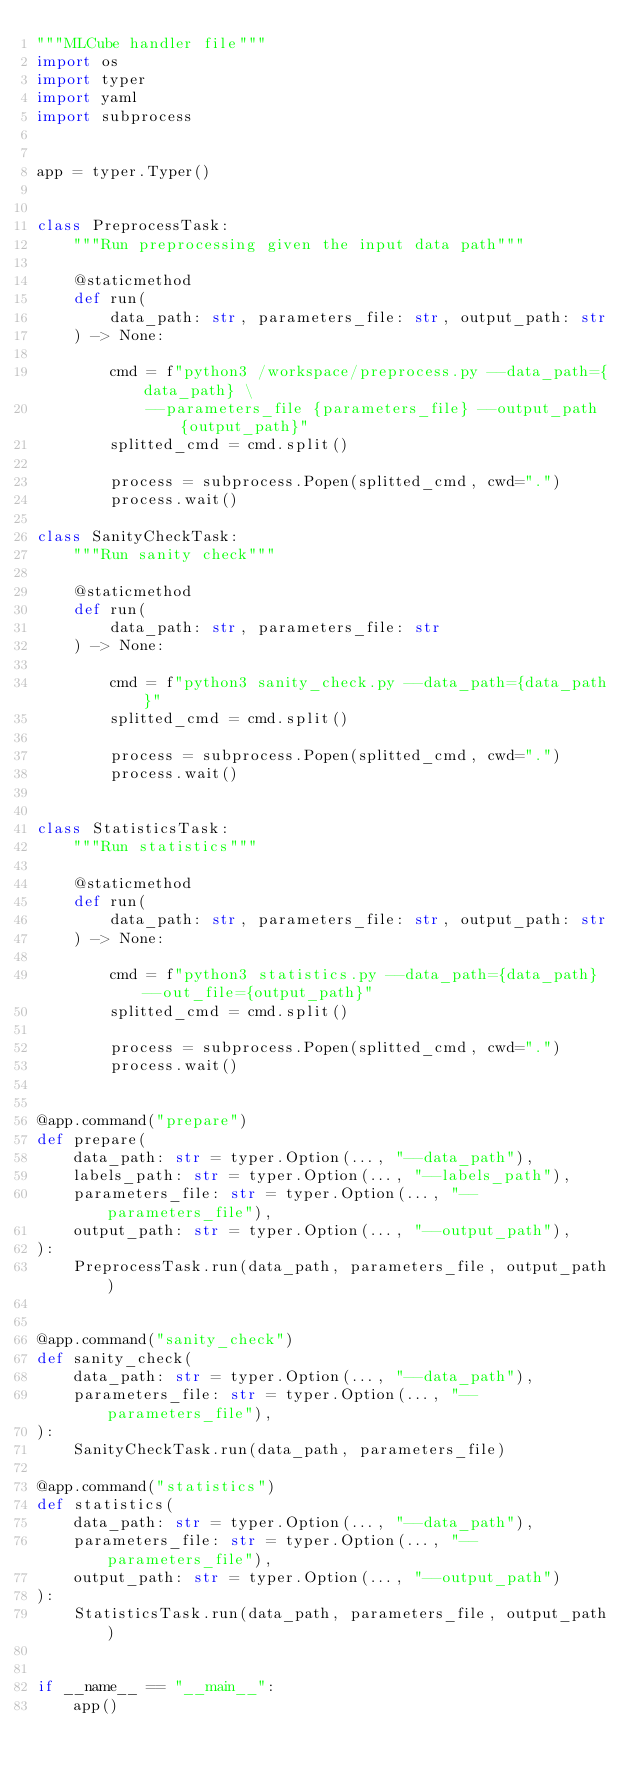Convert code to text. <code><loc_0><loc_0><loc_500><loc_500><_Python_>"""MLCube handler file"""
import os
import typer
import yaml
import subprocess


app = typer.Typer()


class PreprocessTask:
    """Run preprocessing given the input data path"""

    @staticmethod
    def run(
        data_path: str, parameters_file: str, output_path: str
    ) -> None:

        cmd = f"python3 /workspace/preprocess.py --data_path={data_path} \
            --parameters_file {parameters_file} --output_path {output_path}"
        splitted_cmd = cmd.split()

        process = subprocess.Popen(splitted_cmd, cwd=".")
        process.wait()

class SanityCheckTask:
    """Run sanity check"""

    @staticmethod
    def run(
        data_path: str, parameters_file: str
    ) -> None:

        cmd = f"python3 sanity_check.py --data_path={data_path}"
        splitted_cmd = cmd.split()

        process = subprocess.Popen(splitted_cmd, cwd=".")
        process.wait()


class StatisticsTask:
    """Run statistics"""

    @staticmethod
    def run(
        data_path: str, parameters_file: str, output_path: str
    ) -> None:

        cmd = f"python3 statistics.py --data_path={data_path} --out_file={output_path}"
        splitted_cmd = cmd.split()

        process = subprocess.Popen(splitted_cmd, cwd=".")
        process.wait()


@app.command("prepare")
def prepare(
    data_path: str = typer.Option(..., "--data_path"),
    labels_path: str = typer.Option(..., "--labels_path"),
    parameters_file: str = typer.Option(..., "--parameters_file"),
    output_path: str = typer.Option(..., "--output_path"),
):
    PreprocessTask.run(data_path, parameters_file, output_path)


@app.command("sanity_check")
def sanity_check(
    data_path: str = typer.Option(..., "--data_path"),
    parameters_file: str = typer.Option(..., "--parameters_file"),
):
    SanityCheckTask.run(data_path, parameters_file)

@app.command("statistics")
def statistics(
    data_path: str = typer.Option(..., "--data_path"),
    parameters_file: str = typer.Option(..., "--parameters_file"),
    output_path: str = typer.Option(..., "--output_path")
):
    StatisticsTask.run(data_path, parameters_file, output_path)


if __name__ == "__main__":
    app()
</code> 